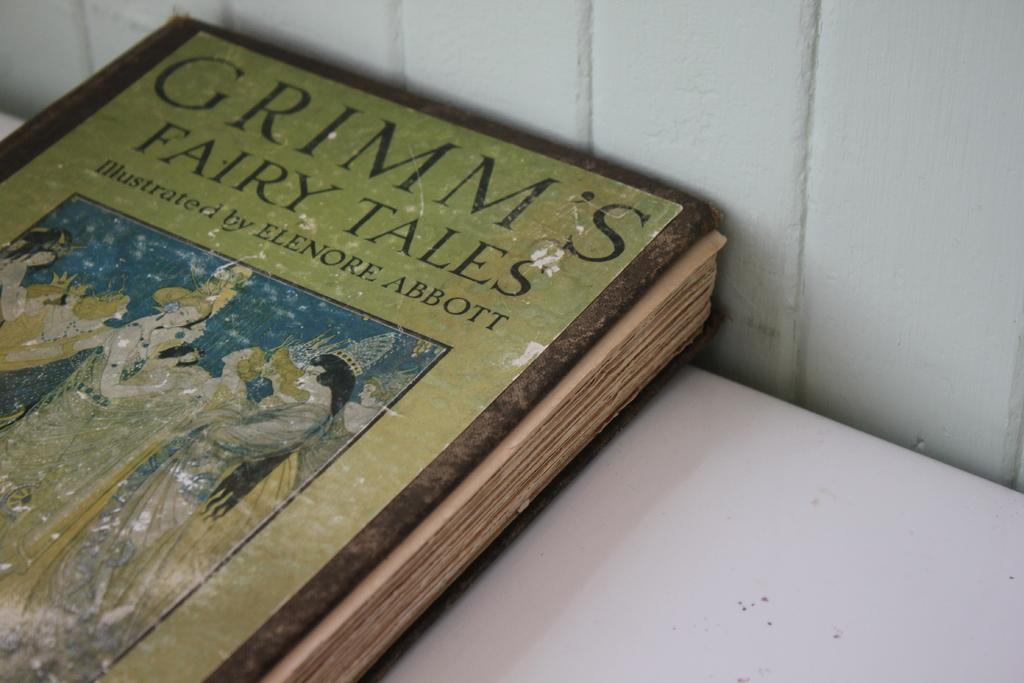<image>
Relay a brief, clear account of the picture shown. An old weathered copy of Grimm's fairy Tales has been illustrated by Elenore Abbott. 